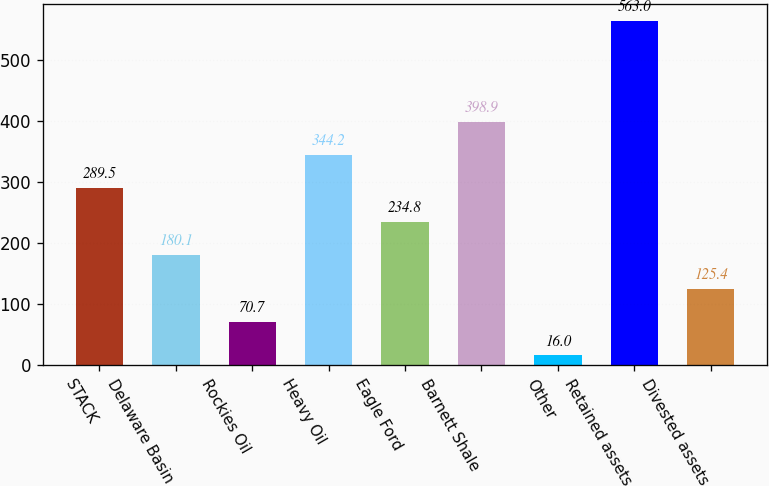<chart> <loc_0><loc_0><loc_500><loc_500><bar_chart><fcel>STACK<fcel>Delaware Basin<fcel>Rockies Oil<fcel>Heavy Oil<fcel>Eagle Ford<fcel>Barnett Shale<fcel>Other<fcel>Retained assets<fcel>Divested assets<nl><fcel>289.5<fcel>180.1<fcel>70.7<fcel>344.2<fcel>234.8<fcel>398.9<fcel>16<fcel>563<fcel>125.4<nl></chart> 